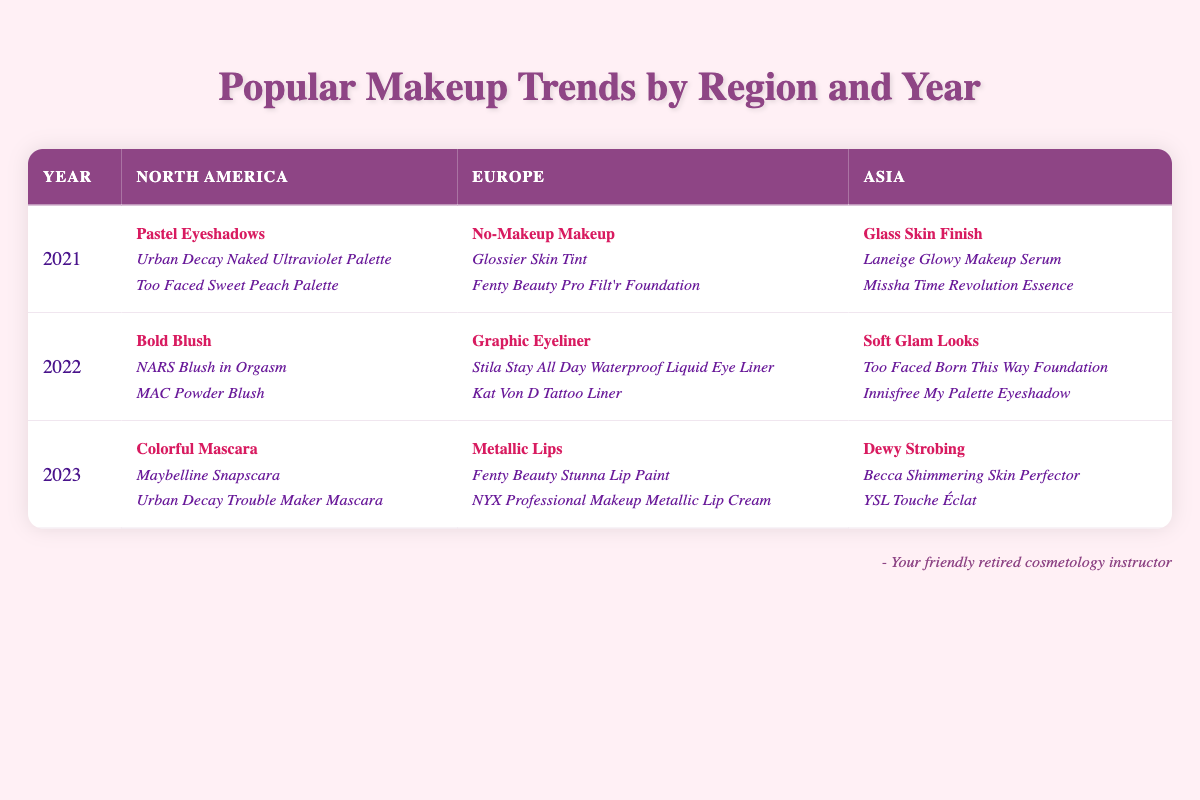What makeup trend was popular in North America in 2022? In the 2022 row, we look under the North America column and find "Bold Blush" listed as the trend.
Answer: Bold Blush Which region had the "No-Makeup Makeup" trend in 2021? We check the 2021 row and see that under the Europe column, "No-Makeup Makeup" is listed.
Answer: Europe Did Asia have a "Glass Skin Finish" trend in 2022? We check the Asia column for the 2022 row and find that "Soft Glam Looks" is listed instead, which means "Glass Skin Finish" was not present.
Answer: No What was the common factor in the popular products for the "Dewy Strobing" trend? "Dewy Strobing" is found in the 2023 Asia column. The popular products listed are "Becca Shimmering Skin Perfector" and "YSL Touche Éclat," both of which are highlighters known for creating a luminous look.
Answer: Highlighters for luminosity How many different trends were listed for Europe across the years? By reviewing the Europe column for each year, we see three different trends: "No-Makeup Makeup" in 2021, "Graphic Eyeliner" in 2022, and "Metallic Lips" in 2023. Therefore, there are three distinct trends.
Answer: Three What is the trend for North America in 2023 and how does it differ from 2021? In 2023, the trend is "Colorful Mascara," while in 2021 the trend was "Pastel Eyeshadows." The difference lies in the 2023 trend focusing on vibrant mascara colors compared to the lighter pastel shades in eyeshadows in 2021.
Answer: Colorful Mascara; Different focus on mascara versus eyeshadows 